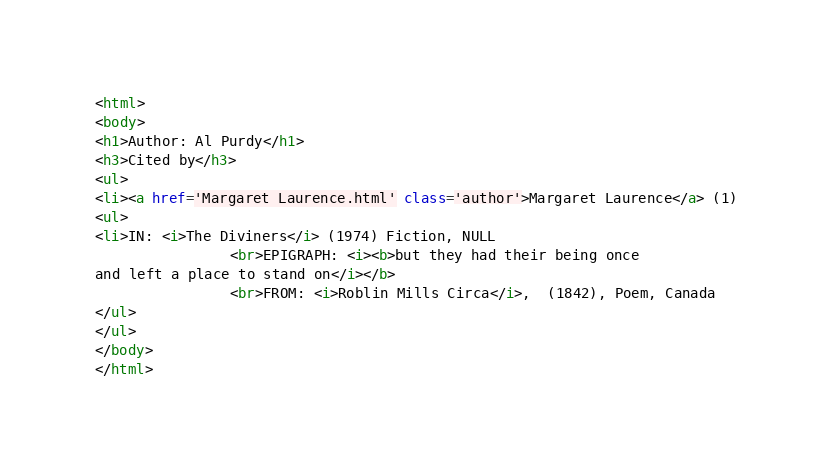<code> <loc_0><loc_0><loc_500><loc_500><_HTML_><html>
<body>
<h1>Author: Al Purdy</h1>
<h3>Cited by</h3>
<ul>
<li><a href='Margaret Laurence.html' class='author'>Margaret Laurence</a> (1)
<ul>
<li>IN: <i>The Diviners</i> (1974) Fiction, NULL
                <br>EPIGRAPH: <i><b>but they had their being once
and left a place to stand on</i></b>
                <br>FROM: <i>Roblin Mills Circa</i>,  (1842), Poem, Canada
</ul>
</ul>
</body>
</html>
</code> 